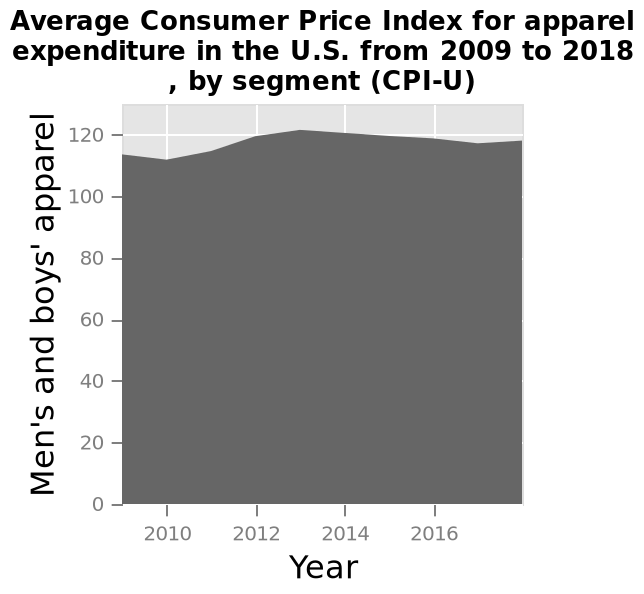<image>
When was the highest price of men's and boys' apparel?  The highest price of men's and boys' apparel was in 2013. 